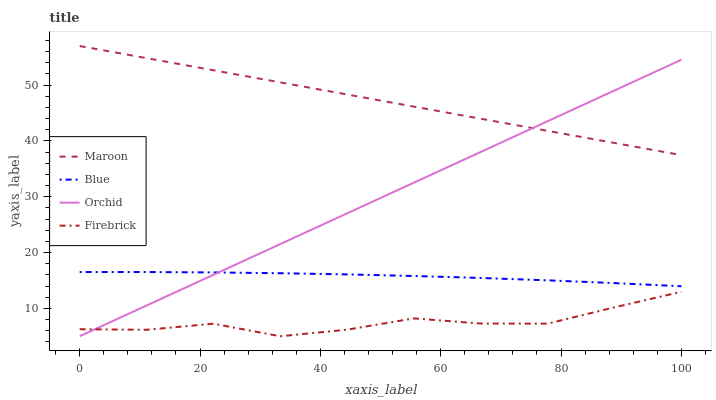Does Firebrick have the minimum area under the curve?
Answer yes or no. Yes. Does Maroon have the maximum area under the curve?
Answer yes or no. Yes. Does Maroon have the minimum area under the curve?
Answer yes or no. No. Does Firebrick have the maximum area under the curve?
Answer yes or no. No. Is Orchid the smoothest?
Answer yes or no. Yes. Is Firebrick the roughest?
Answer yes or no. Yes. Is Maroon the smoothest?
Answer yes or no. No. Is Maroon the roughest?
Answer yes or no. No. Does Maroon have the lowest value?
Answer yes or no. No. Does Firebrick have the highest value?
Answer yes or no. No. Is Blue less than Maroon?
Answer yes or no. Yes. Is Blue greater than Firebrick?
Answer yes or no. Yes. Does Blue intersect Maroon?
Answer yes or no. No. 